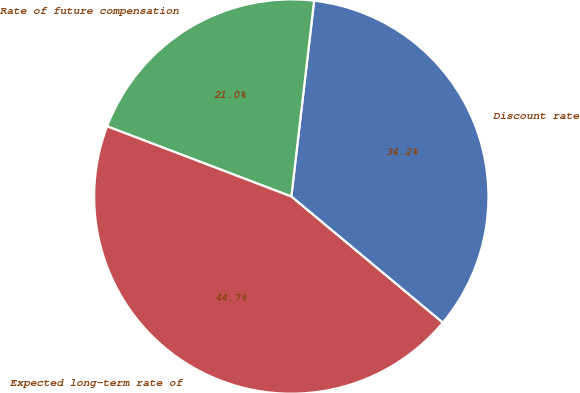Convert chart to OTSL. <chart><loc_0><loc_0><loc_500><loc_500><pie_chart><fcel>Discount rate<fcel>Rate of future compensation<fcel>Expected long-term rate of<nl><fcel>34.21%<fcel>21.05%<fcel>44.74%<nl></chart> 